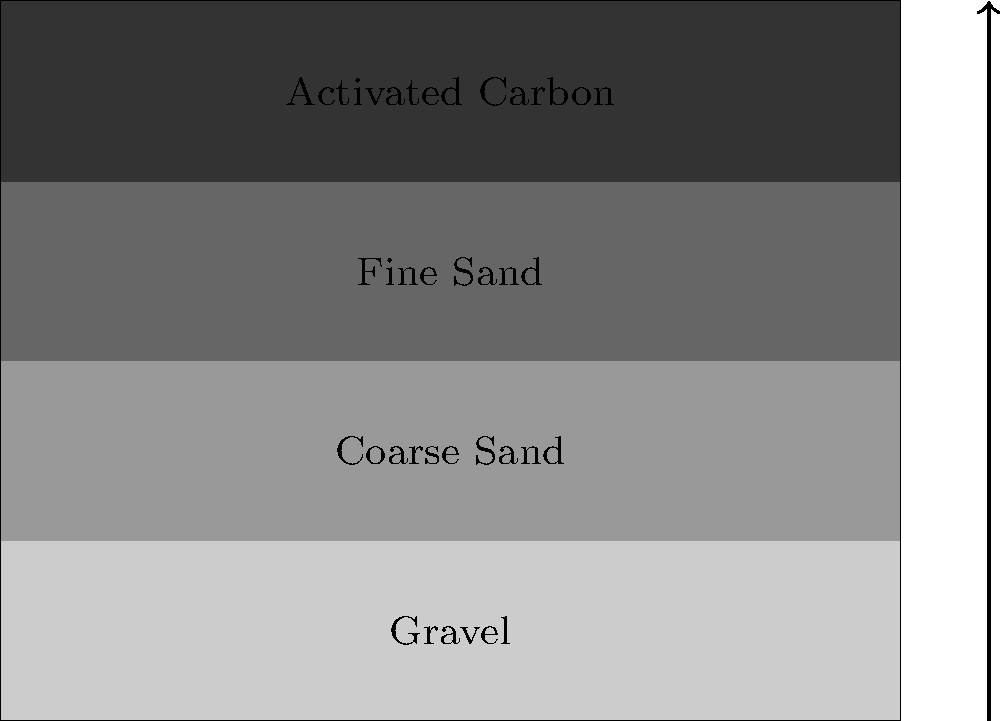As a descendant of Enright settlers, you're tasked with designing a basic water filtration system for your community. Based on the cross-sectional view provided, what is the correct order of filter layers from bottom to top, and why is this arrangement effective for water purification? The arrangement of filter layers in a basic water filtration system is crucial for effective purification. Let's examine the layers from bottom to top:

1. Gravel (bottom layer):
   - Acts as a support layer
   - Allows for even water distribution
   - Prevents finer materials from clogging the system

2. Coarse Sand:
   - Filters out larger particles
   - Improves water flow

3. Fine Sand:
   - Removes smaller particles and some bacteria
   - Increases surface area for filtration

4. Activated Carbon (top layer):
   - Adsorbs chemicals, odors, and some contaminants
   - Improves taste and smell of water

This arrangement is effective because:
- It follows a gradient from larger to smaller particle sizes
- Each layer targets different contaminants
- It allows for proper water flow while maximizing filtration efficiency

The water flows from top to bottom, with each layer progressively removing smaller particles and contaminants. This design ensures that larger particles are removed first, preventing clogging of finer filtration layers and extending the system's lifespan.
Answer: Gravel, Coarse Sand, Fine Sand, Activated Carbon (bottom to top) 